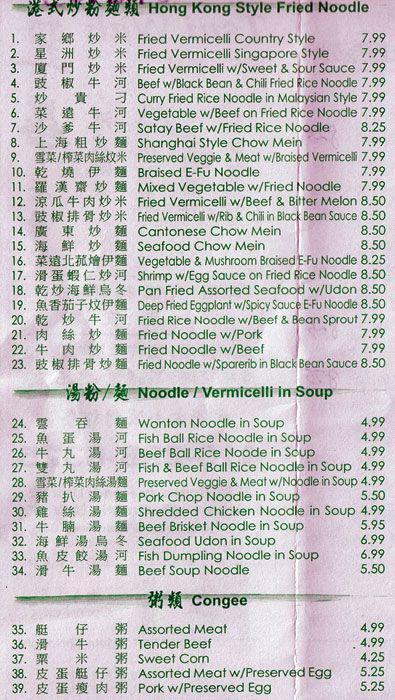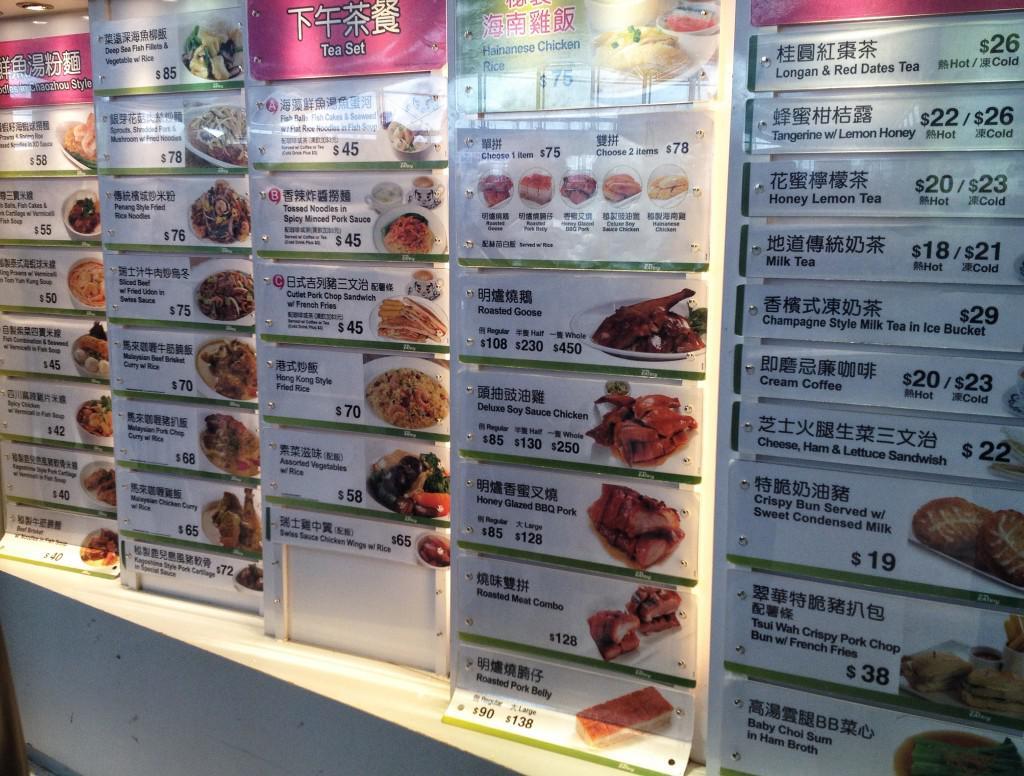The first image is the image on the left, the second image is the image on the right. Assess this claim about the two images: "One of the menus features over twenty pictures of the items.". Correct or not? Answer yes or no. Yes. The first image is the image on the left, the second image is the image on the right. Given the left and right images, does the statement "There are five lined menus in a row with pink headers." hold true? Answer yes or no. Yes. 